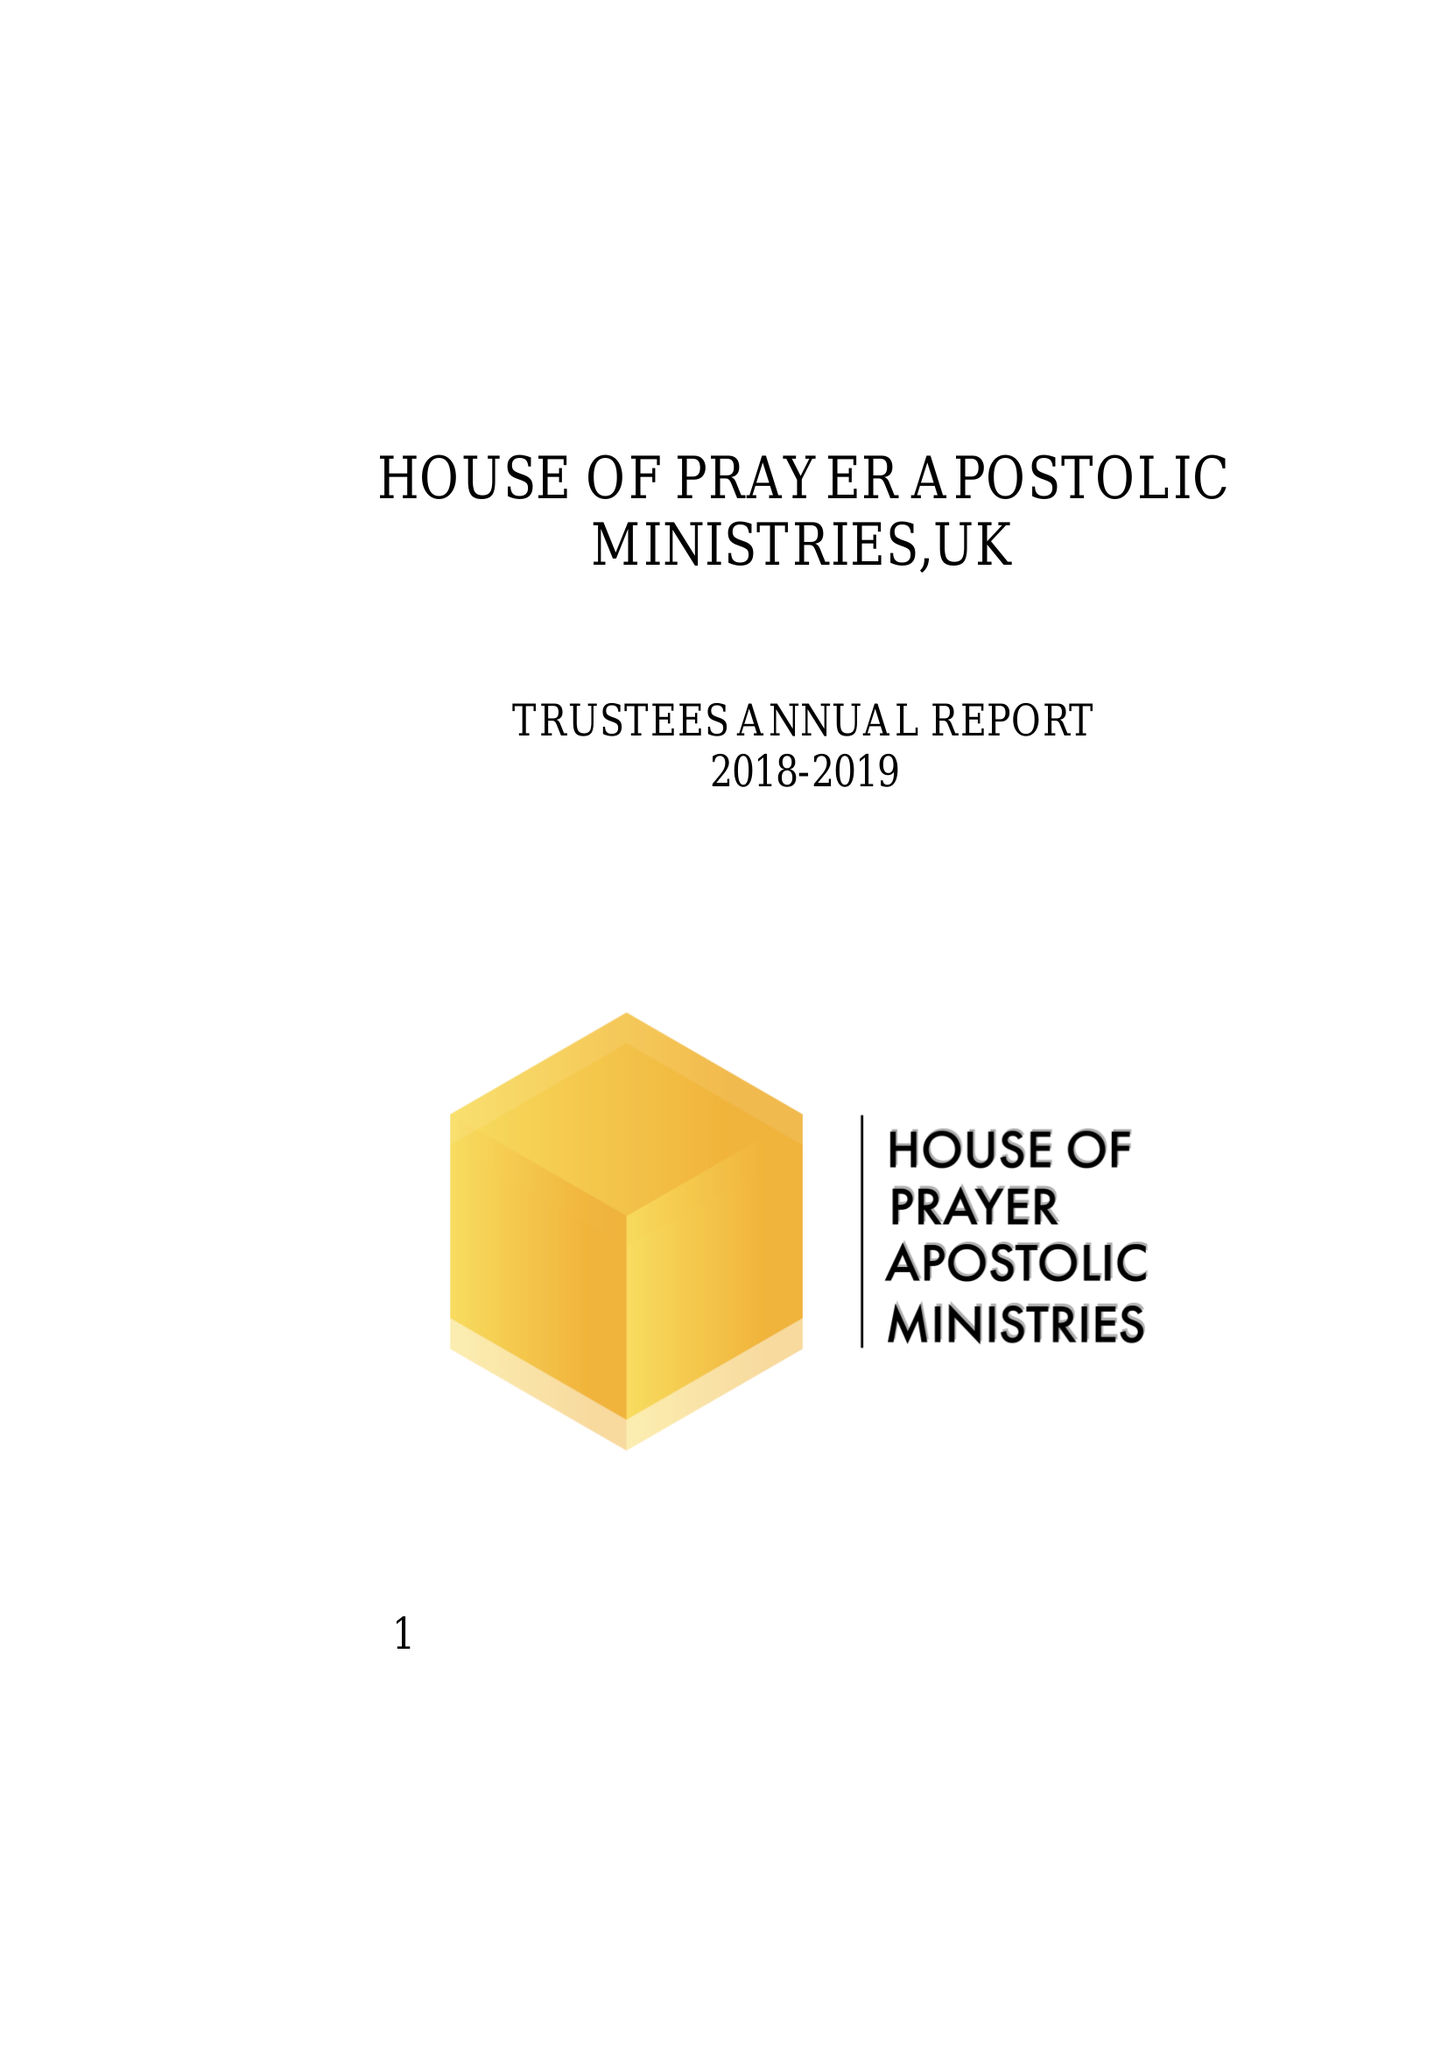What is the value for the report_date?
Answer the question using a single word or phrase. 2018-03-31 